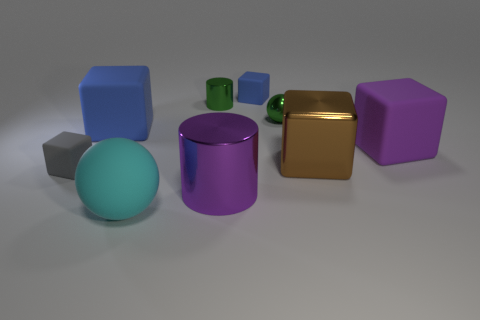Subtract all purple cubes. How many cubes are left? 4 Subtract all small gray matte cubes. How many cubes are left? 4 Subtract all red cubes. Subtract all green cylinders. How many cubes are left? 5 Add 1 large yellow things. How many objects exist? 10 Subtract all cylinders. How many objects are left? 7 Subtract 0 blue spheres. How many objects are left? 9 Subtract all small cyan cubes. Subtract all metal balls. How many objects are left? 8 Add 6 blue things. How many blue things are left? 8 Add 5 tiny balls. How many tiny balls exist? 6 